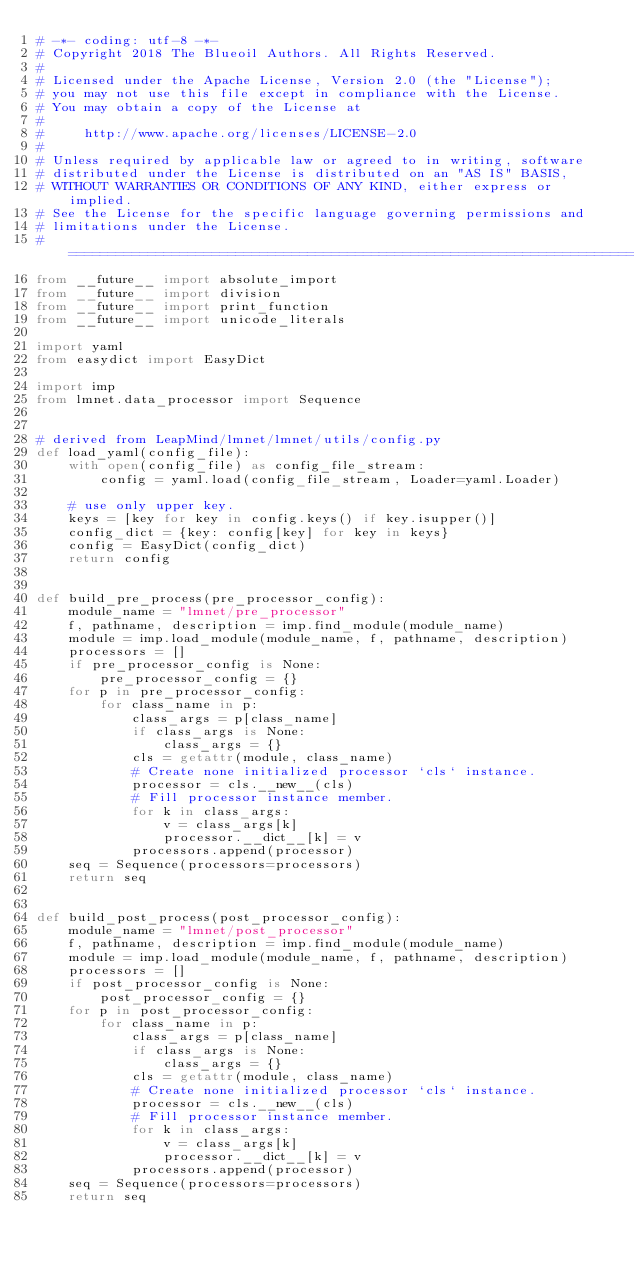Convert code to text. <code><loc_0><loc_0><loc_500><loc_500><_Python_># -*- coding: utf-8 -*-
# Copyright 2018 The Blueoil Authors. All Rights Reserved.
#
# Licensed under the Apache License, Version 2.0 (the "License");
# you may not use this file except in compliance with the License.
# You may obtain a copy of the License at
#
#     http://www.apache.org/licenses/LICENSE-2.0
#
# Unless required by applicable law or agreed to in writing, software
# distributed under the License is distributed on an "AS IS" BASIS,
# WITHOUT WARRANTIES OR CONDITIONS OF ANY KIND, either express or implied.
# See the License for the specific language governing permissions and
# limitations under the License.
# =============================================================================
from __future__ import absolute_import
from __future__ import division
from __future__ import print_function
from __future__ import unicode_literals

import yaml
from easydict import EasyDict

import imp
from lmnet.data_processor import Sequence


# derived from LeapMind/lmnet/lmnet/utils/config.py
def load_yaml(config_file):
    with open(config_file) as config_file_stream:
        config = yaml.load(config_file_stream, Loader=yaml.Loader)

    # use only upper key.
    keys = [key for key in config.keys() if key.isupper()]
    config_dict = {key: config[key] for key in keys}
    config = EasyDict(config_dict)
    return config


def build_pre_process(pre_processor_config):
    module_name = "lmnet/pre_processor"
    f, pathname, description = imp.find_module(module_name)
    module = imp.load_module(module_name, f, pathname, description)
    processors = []
    if pre_processor_config is None:
        pre_processor_config = {}
    for p in pre_processor_config:
        for class_name in p:
            class_args = p[class_name]
            if class_args is None:
                class_args = {}
            cls = getattr(module, class_name)
            # Create none initialized processor `cls` instance.
            processor = cls.__new__(cls)
            # Fill processor instance member.
            for k in class_args:
                v = class_args[k]
                processor.__dict__[k] = v
            processors.append(processor)
    seq = Sequence(processors=processors)
    return seq


def build_post_process(post_processor_config):
    module_name = "lmnet/post_processor"
    f, pathname, description = imp.find_module(module_name)
    module = imp.load_module(module_name, f, pathname, description)
    processors = []
    if post_processor_config is None:
        post_processor_config = {}
    for p in post_processor_config:
        for class_name in p:
            class_args = p[class_name]
            if class_args is None:
                class_args = {}
            cls = getattr(module, class_name)
            # Create none initialized processor `cls` instance.
            processor = cls.__new__(cls)
            # Fill processor instance member.
            for k in class_args:
                v = class_args[k]
                processor.__dict__[k] = v
            processors.append(processor)
    seq = Sequence(processors=processors)
    return seq
</code> 